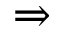<formula> <loc_0><loc_0><loc_500><loc_500>\Rightarrow</formula> 